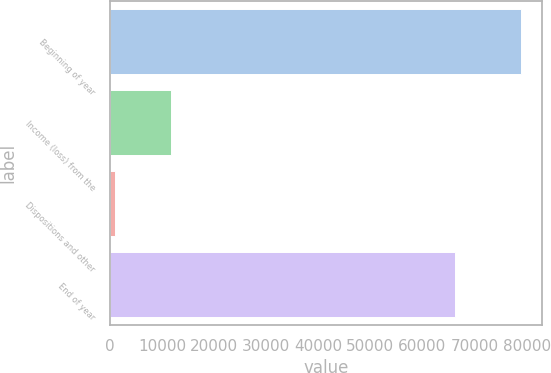Convert chart. <chart><loc_0><loc_0><loc_500><loc_500><bar_chart><fcel>Beginning of year<fcel>Income (loss) from the<fcel>Dispositions and other<fcel>End of year<nl><fcel>78992<fcel>11684<fcel>1061<fcel>66247<nl></chart> 